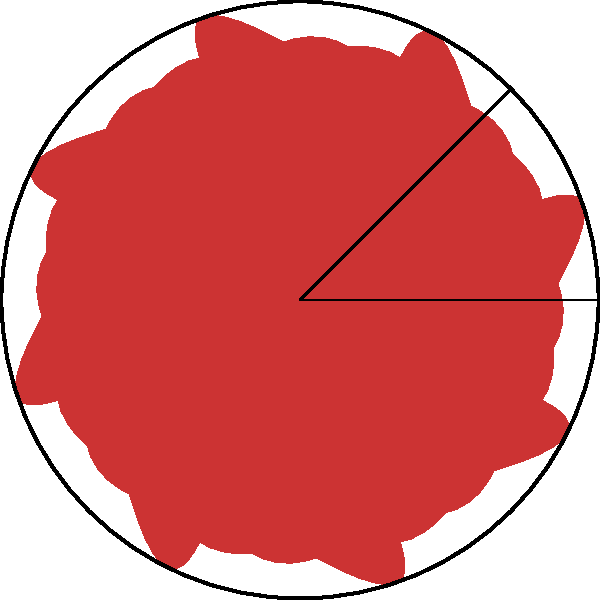A traditional Norwegian rosemaling design features a circular pattern with 8 identical flower petals, as shown in the image. What is the order of the rotational symmetry group for this design, and what is the smallest non-identity rotation angle in degrees? To determine the order of the rotational symmetry group and the smallest non-identity rotation angle, we need to follow these steps:

1. Observe the design: The pattern has 8 identical flower petals arranged in a circular manner.

2. Determine the order of the rotational symmetry group:
   - The order is the number of distinct rotations that bring the design back to its original position.
   - In this case, we can rotate the design by 45°, 90°, 135°, 180°, 225°, 270°, 315°, and 360° (which is equivalent to 0° or no rotation).
   - There are 8 distinct rotations, including the identity rotation (360° or 0°).
   - Therefore, the order of the rotational symmetry group is 8.

3. Find the smallest non-identity rotation angle:
   - The smallest rotation that brings the design to a new, symmetric position is the angle between two adjacent petals.
   - Since there are 8 petals evenly distributed around 360°, the angle between each petal is 360° ÷ 8 = 45°.
   - Thus, the smallest non-identity rotation angle is 45°.

The rotational symmetry group of this design is isomorphic to the cyclic group $C_8$ or $\mathbb{Z}_8$.
Answer: Order: 8; Smallest non-identity rotation angle: 45° 